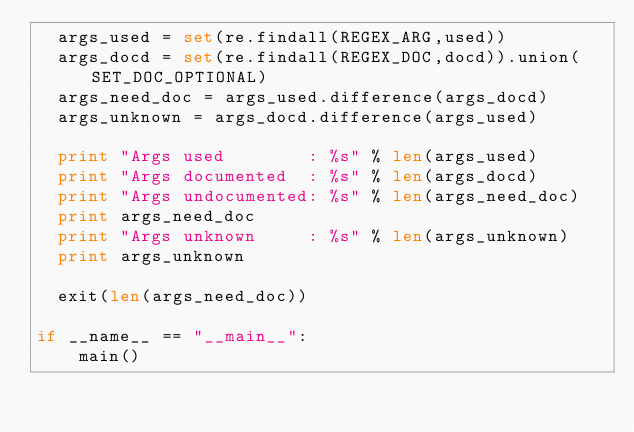<code> <loc_0><loc_0><loc_500><loc_500><_Python_>  args_used = set(re.findall(REGEX_ARG,used))
  args_docd = set(re.findall(REGEX_DOC,docd)).union(SET_DOC_OPTIONAL)
  args_need_doc = args_used.difference(args_docd)
  args_unknown = args_docd.difference(args_used)

  print "Args used        : %s" % len(args_used)
  print "Args documented  : %s" % len(args_docd)
  print "Args undocumented: %s" % len(args_need_doc)
  print args_need_doc
  print "Args unknown     : %s" % len(args_unknown)
  print args_unknown

  exit(len(args_need_doc))

if __name__ == "__main__":
    main()
</code> 